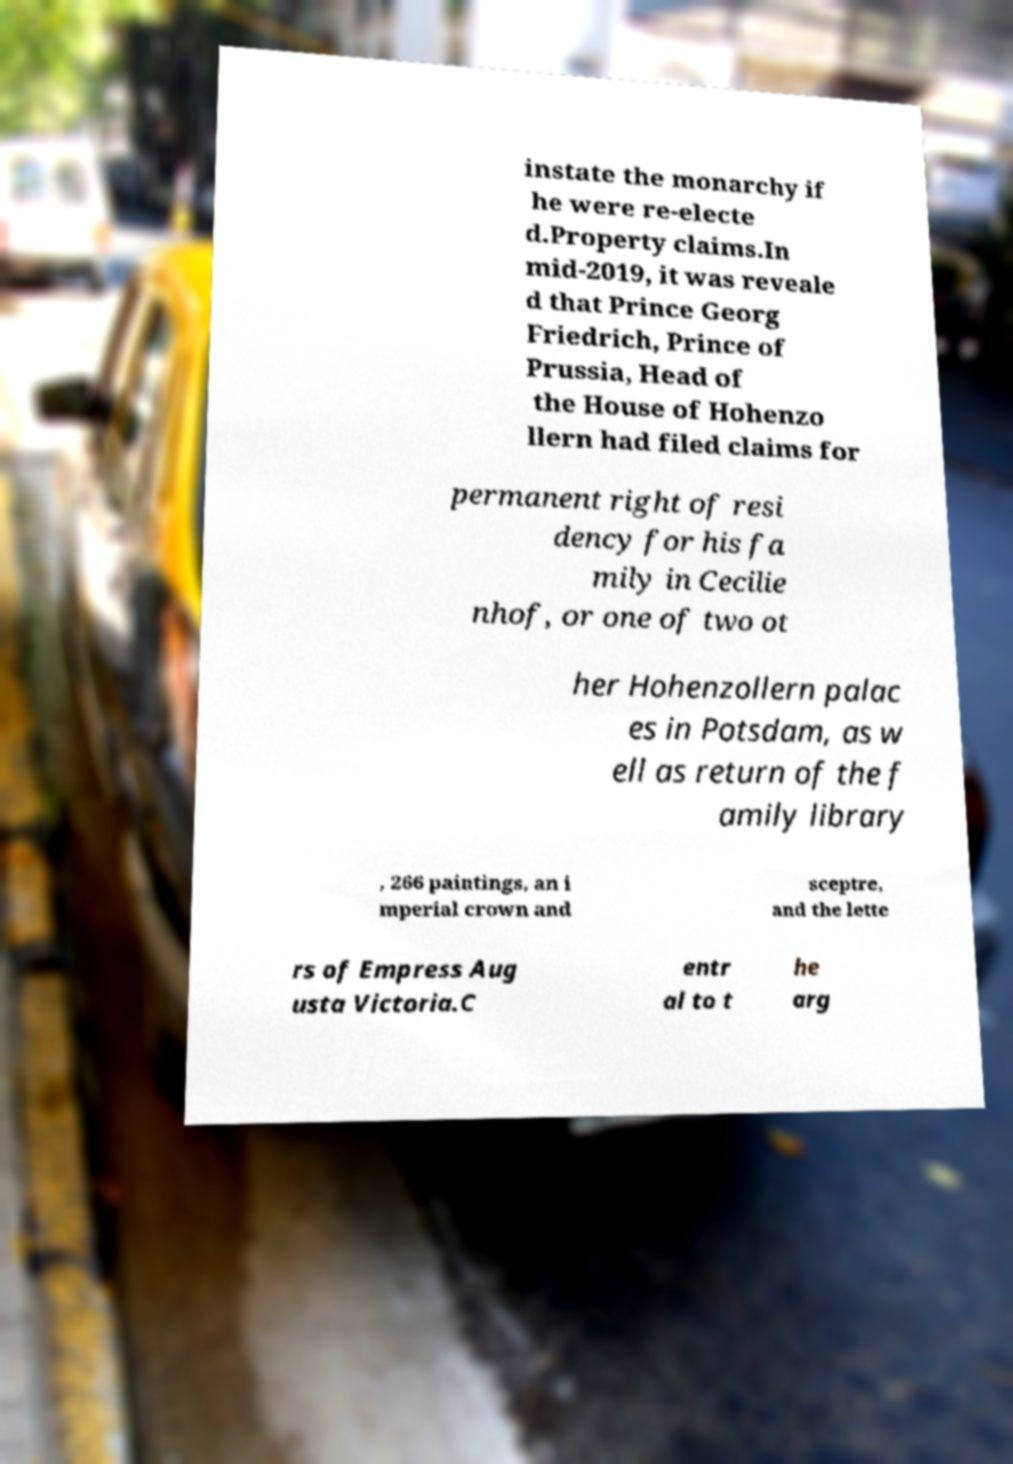Please identify and transcribe the text found in this image. instate the monarchy if he were re-electe d.Property claims.In mid-2019, it was reveale d that Prince Georg Friedrich, Prince of Prussia, Head of the House of Hohenzo llern had filed claims for permanent right of resi dency for his fa mily in Cecilie nhof, or one of two ot her Hohenzollern palac es in Potsdam, as w ell as return of the f amily library , 266 paintings, an i mperial crown and sceptre, and the lette rs of Empress Aug usta Victoria.C entr al to t he arg 